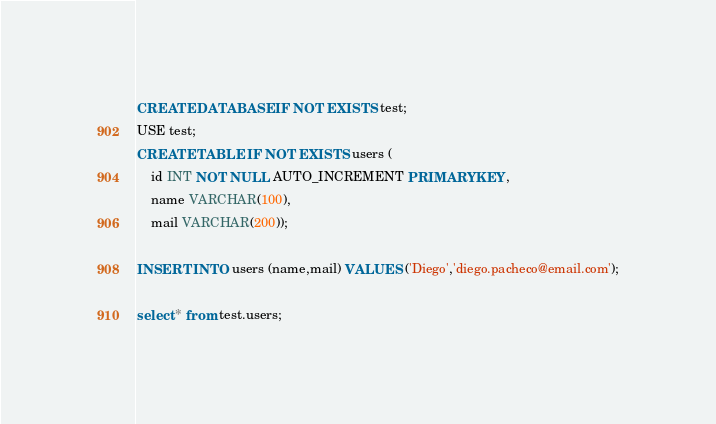<code> <loc_0><loc_0><loc_500><loc_500><_SQL_>CREATE DATABASE IF NOT EXISTS test;
USE test;
CREATE TABLE IF NOT EXISTS users (
    id INT NOT NULL AUTO_INCREMENT PRIMARY KEY,
    name VARCHAR(100),
    mail VARCHAR(200));

INSERT INTO users (name,mail) VALUES ('Diego','diego.pacheco@email.com');

select * from test.users;</code> 